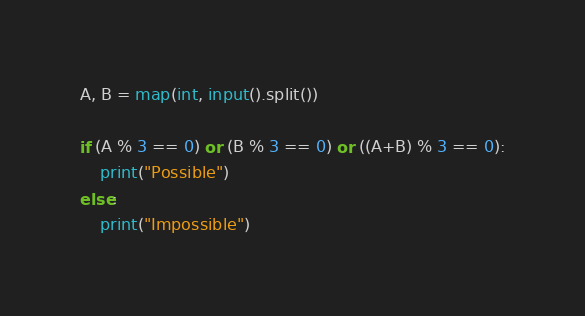<code> <loc_0><loc_0><loc_500><loc_500><_Python_>A, B = map(int, input().split())
 
if (A % 3 == 0) or (B % 3 == 0) or ((A+B) % 3 == 0):
    print("Possible")
else:
    print("Impossible")</code> 